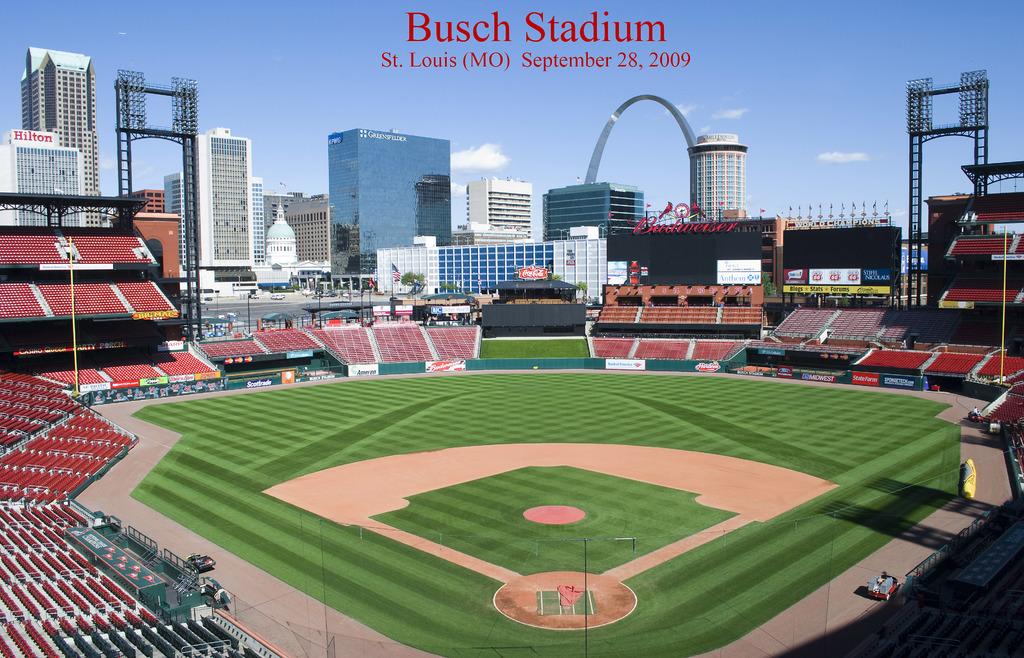What is the name of this stadium?
Provide a succinct answer. Busch stadium. 